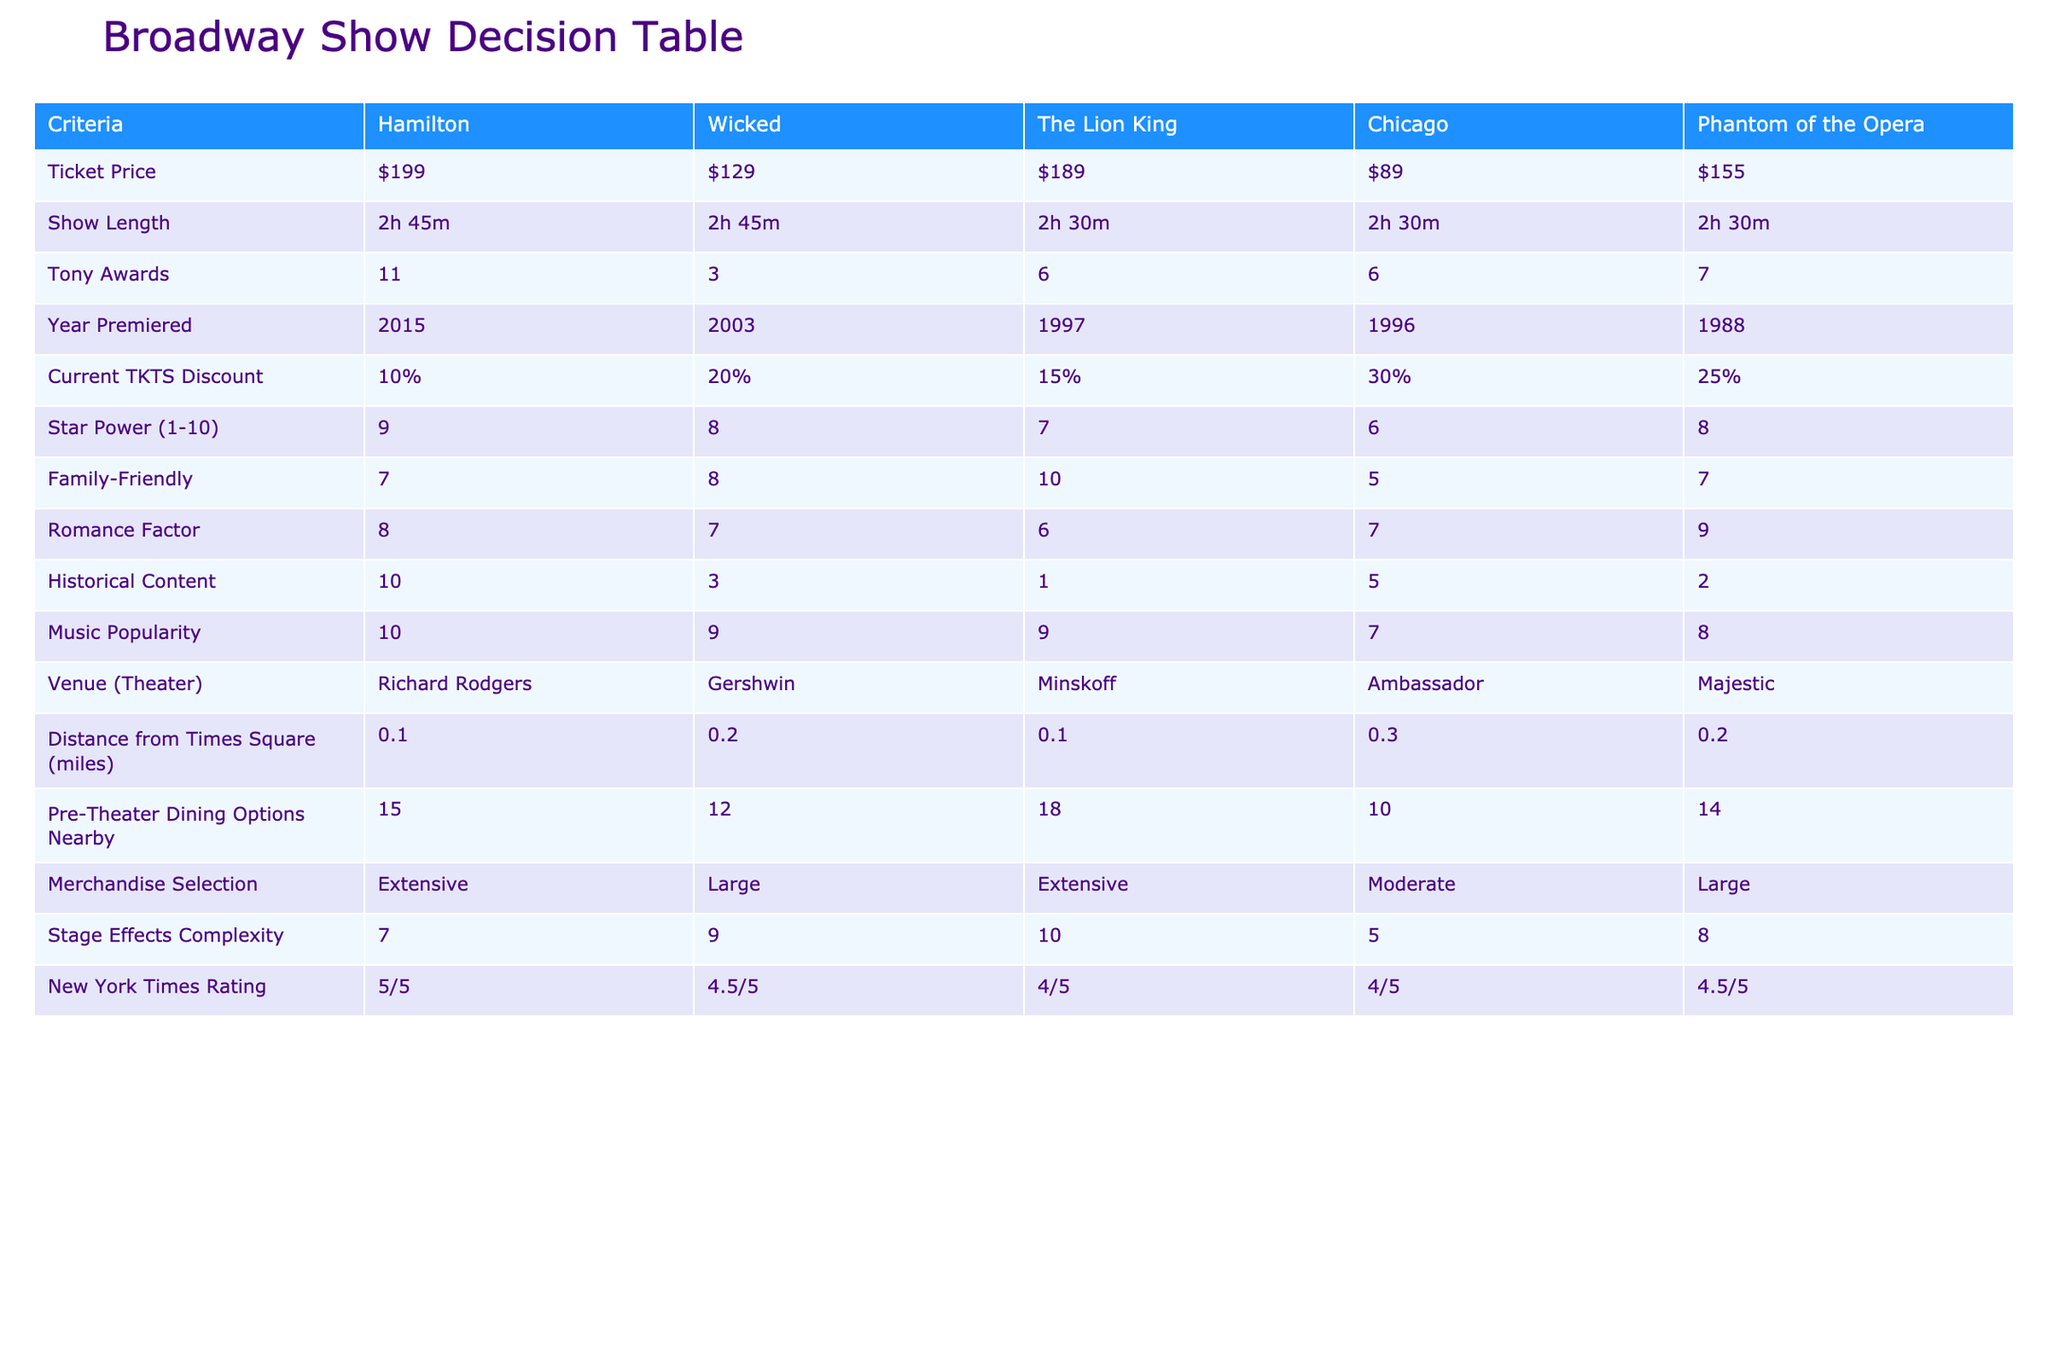What is the ticket price for 'Wicked'? The ticket price for 'Wicked' is directly listed in the table. It shows that the price is $129.
Answer: $129 Which show has the longest show length? The show lengths for each title are all reported, and both 'Hamilton' and 'Wicked' have a show length of 2 hours and 45 minutes, making them the longest.
Answer: Hamilton and Wicked What is the family-friendly rating of 'Chicago'? The family-friendly rating for 'Chicago' is clearly marked in the table as 5.
Answer: 5 What is the average ticket price of the three shows with the most Tony Awards? First, identify the three shows with the most Tony Awards: 'Hamilton' (11), 'Phantom of the Opera' (7), and 'The Lion King' (6). Their ticket prices are $199, $155, and $189 respectively. Sum these ($199 + $155 + $189 = $543) and divide by 3 for the average, which is $543/3 = $181.
Answer: $181 Is 'The Lion King' more family-friendly than 'Phantom of the Opera'? The family-friendly ratings are listed: 'The Lion King' has a rating of 10, while 'Phantom of the Opera' has a rating of 7. Since 10 is greater than 7, 'The Lion King' is indeed more family-friendly.
Answer: Yes What percentage discount is currently available for 'Chicago'? The table shows the current TKTS discount for 'Chicago' as 30%.
Answer: 30% Which show premiered the earliest? The premiere years are listed, with 'The Lion King' premiering in 1997, making it the earliest among the shows.
Answer: The Lion King What is the total number of Tony Awards for all shows combined? Adding the Tony Awards for each show: 11 (Hamilton) + 3 (Wicked) + 6 (The Lion King) + 6 (Chicago) + 7 (Phantom of the Opera) gives a total of 33 Tony Awards across all shows.
Answer: 33 Does 'Wicked' have a higher music popularity rating than 'Chicago'? The music popularity ratings indicate 'Wicked' has a rating of 9 while 'Chicago' has a rating of 7. Since 9 is greater than 7, 'Wicked' indeed has a higher rating.
Answer: Yes 